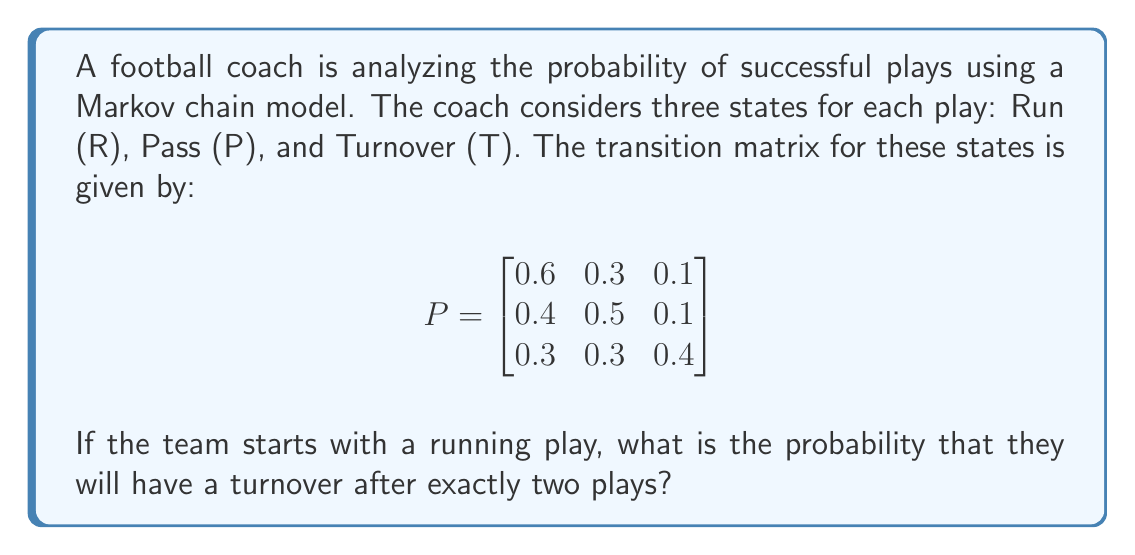What is the answer to this math problem? To solve this problem, we'll use the Markov chain transition matrix and calculate the probability of reaching the Turnover state after two transitions, starting from the Run state.

Step 1: Identify the initial state vector.
Since we start with a running play, our initial state vector is:
$$v_0 = \begin{bmatrix} 1 & 0 & 0 \end{bmatrix}$$

Step 2: Calculate the state after one transition.
$$v_1 = v_0 P = \begin{bmatrix} 1 & 0 & 0 \end{bmatrix} \begin{bmatrix}
0.6 & 0.3 & 0.1 \\
0.4 & 0.5 & 0.1 \\
0.3 & 0.3 & 0.4
\end{bmatrix} = \begin{bmatrix} 0.6 & 0.3 & 0.1 \end{bmatrix}$$

Step 3: Calculate the state after two transitions.
$$v_2 = v_1 P = \begin{bmatrix} 0.6 & 0.3 & 0.1 \end{bmatrix} \begin{bmatrix}
0.6 & 0.3 & 0.1 \\
0.4 & 0.5 & 0.1 \\
0.3 & 0.3 & 0.4
\end{bmatrix}$$

Step 4: Perform the matrix multiplication.
$$v_2 = \begin{bmatrix} (0.6 \times 0.6 + 0.3 \times 0.4 + 0.1 \times 0.3) & (0.6 \times 0.3 + 0.3 \times 0.5 + 0.1 \times 0.3) & (0.6 \times 0.1 + 0.3 \times 0.1 + 0.1 \times 0.4) \end{bmatrix}$$

$$v_2 = \begin{bmatrix} 0.51 & 0.33 & 0.16 \end{bmatrix}$$

Step 5: Identify the probability of being in the Turnover state after two plays.
The Turnover state is represented by the third element in the vector, which is 0.16.

Therefore, the probability of having a turnover after exactly two plays, starting with a running play, is 0.16 or 16%.
Answer: 0.16 